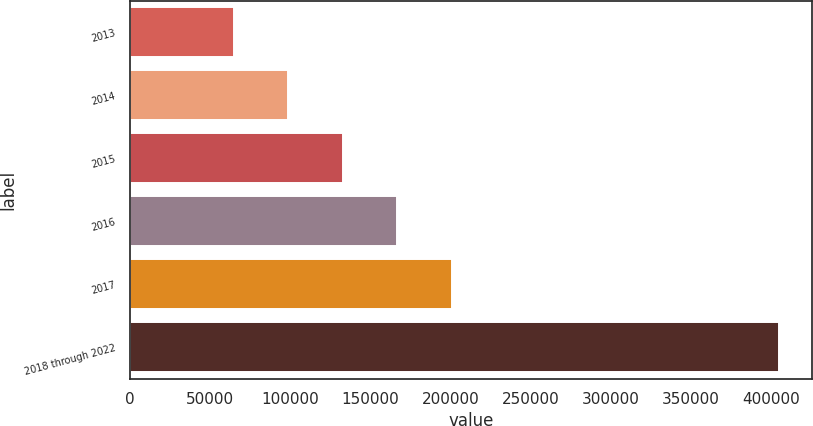<chart> <loc_0><loc_0><loc_500><loc_500><bar_chart><fcel>2013<fcel>2014<fcel>2015<fcel>2016<fcel>2017<fcel>2018 through 2022<nl><fcel>64821<fcel>98833.6<fcel>132846<fcel>166859<fcel>200871<fcel>404947<nl></chart> 